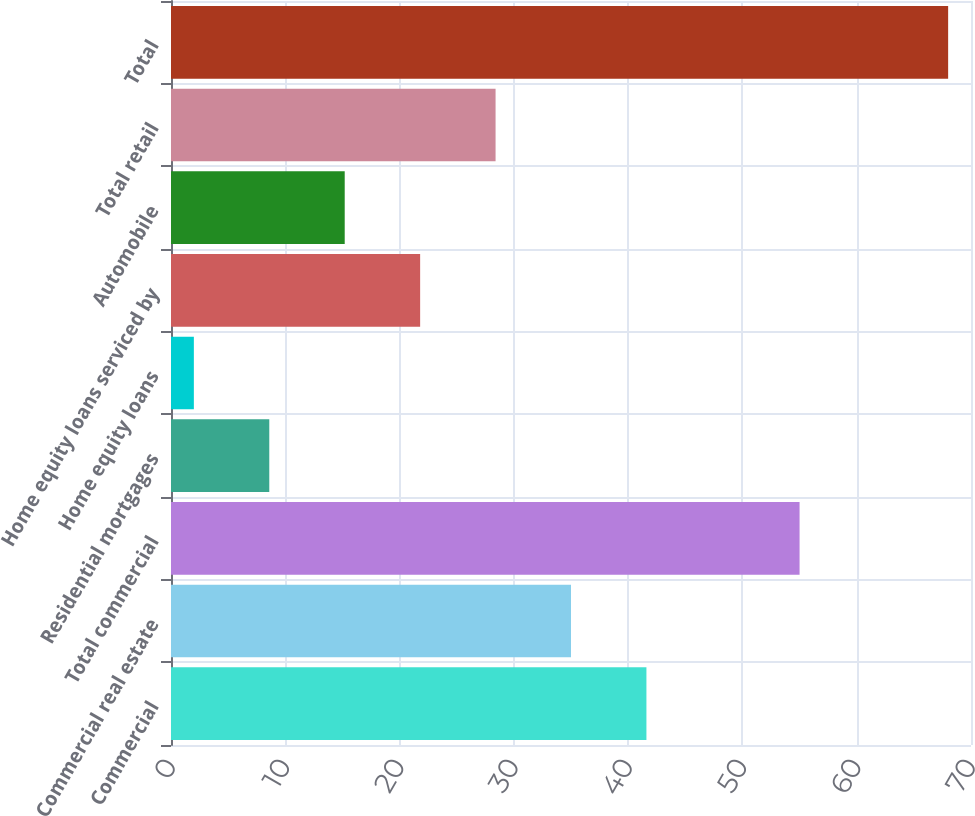<chart> <loc_0><loc_0><loc_500><loc_500><bar_chart><fcel>Commercial<fcel>Commercial real estate<fcel>Total commercial<fcel>Residential mortgages<fcel>Home equity loans<fcel>Home equity loans serviced by<fcel>Automobile<fcel>Total retail<fcel>Total<nl><fcel>41.6<fcel>35<fcel>55<fcel>8.6<fcel>2<fcel>21.8<fcel>15.2<fcel>28.4<fcel>68<nl></chart> 